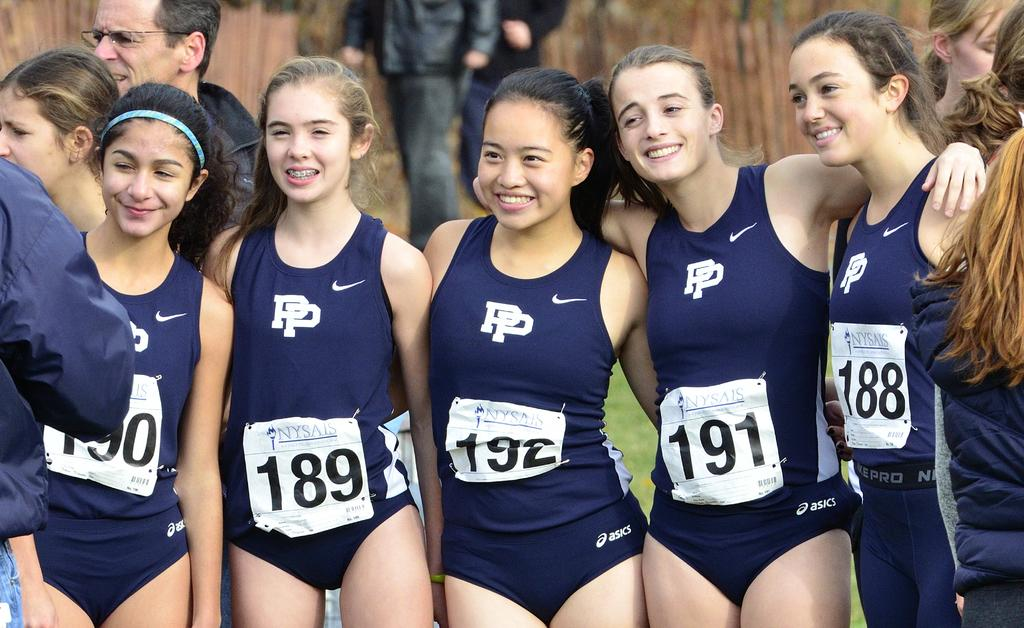<image>
Provide a brief description of the given image. A group of female athletes wearing stand together, with player 192 in the center. 